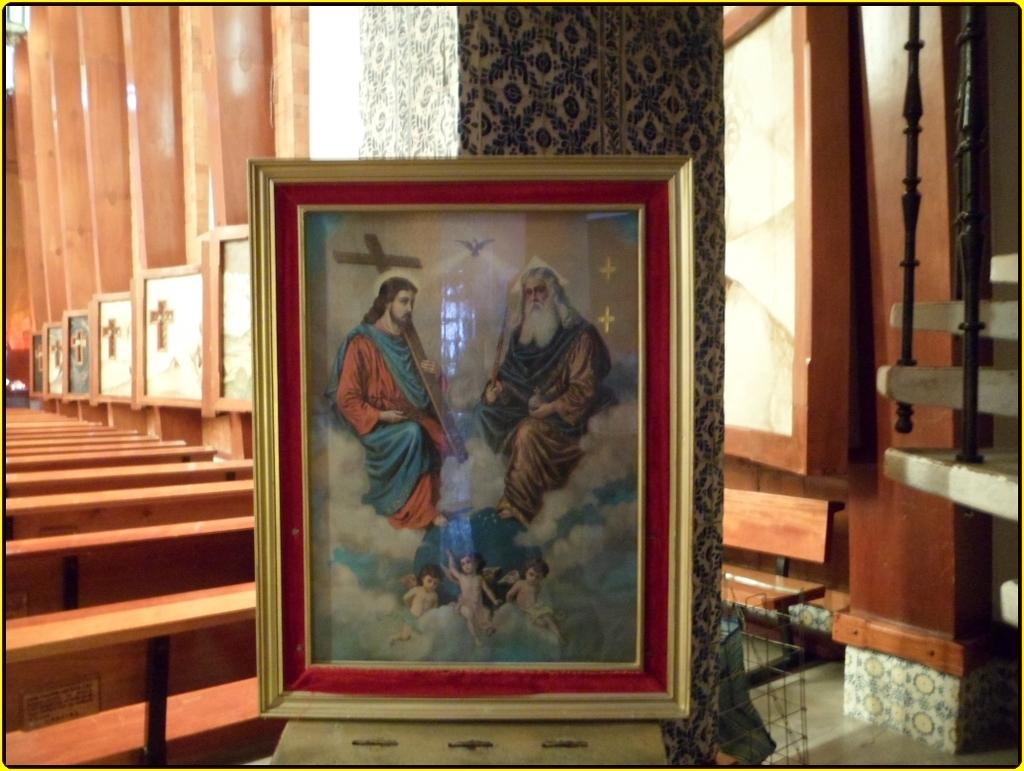What type of structure can be seen in the image? There is a wall in the image. What type of seating is available in the image? There are benches in the image. What type of decorative items are present in the image? There are photo frames in the image. Can you tell me who won the argument in the image? There is no argument present in the image; it only features a wall, benches, and photo frames. What type of stone is used to build the wall in the image? The type of stone used to build the wall is not visible or mentioned in the image. 